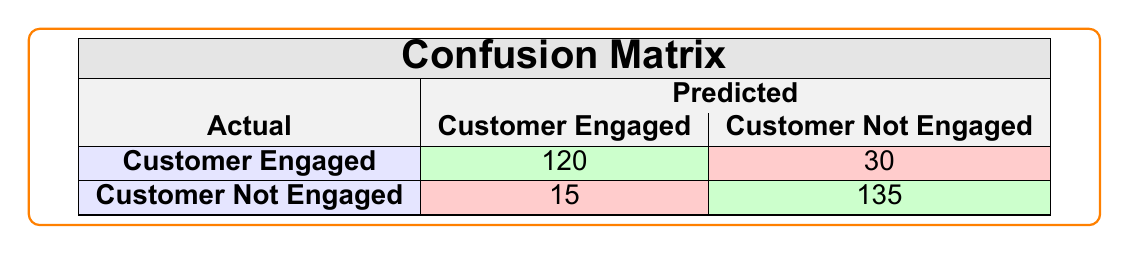What is the number of customers predicted to be engaged that were actually engaged? The table shows that the predicted number of customers engaged who were actually engaged is represented in the cell where "Customer Engaged" crosses "Customer Engaged," which has a value of 120.
Answer: 120 What is the count of customers predicted to be not engaged but were actually engaged? This is found at the intersection of "Customer Engaged" and "Customer Not Engaged," which has a value of 30.
Answer: 30 What is the sum of all true negative predictions? True negatives are those correctly predicted as "Customer Not Engaged," which can be found in the cell where "Customer Not Engaged" intersects with "Customer Not Engaged," having a value of 135. Therefore, the sum of true negative predictions is 135.
Answer: 135 Is there a higher number of customers predicted to be engaged than not engaged? To check this, we compare the total predictions for "Customer Engaged" (120 + 30 = 150) with "Customer Not Engaged" (15 + 135 = 150). Since both totals are equal, the answer is no.
Answer: No What percentage of customers who were actually engaged did the model predict correctly? The number of correct predictions for engaged customers is 120 out of the total engaged customers, which is (120 + 30) = 150. The percentage is calculated as (120 / 150) * 100 = 80%.
Answer: 80% How many customers were incorrectly predicted as engaged? The incorrectly predicted engaged customers are those who were not engaged but predicted as engaged, which is represented in the cell where "Customer Not Engaged" crosses "Customer Engaged" with a count of 15.
Answer: 15 What is the total number of predictions made for both categories? To find the total predictions, sum all the values in the table: 120 + 30 + 15 + 135 = 300.
Answer: 300 What is the accuracy of the model in predicting customer engagement? Accuracy is calculated as the ratio of correct predictions to total predictions. In this case, correct predictions are (120 + 135) = 255 and total predictions are 300. Therefore, accuracy is (255 / 300) * 100 = 85%.
Answer: 85% 